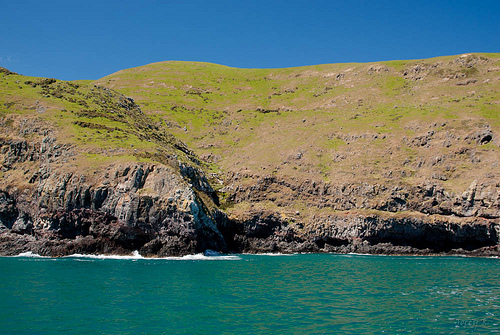<image>
Can you confirm if the grass is next to the water? Yes. The grass is positioned adjacent to the water, located nearby in the same general area. 